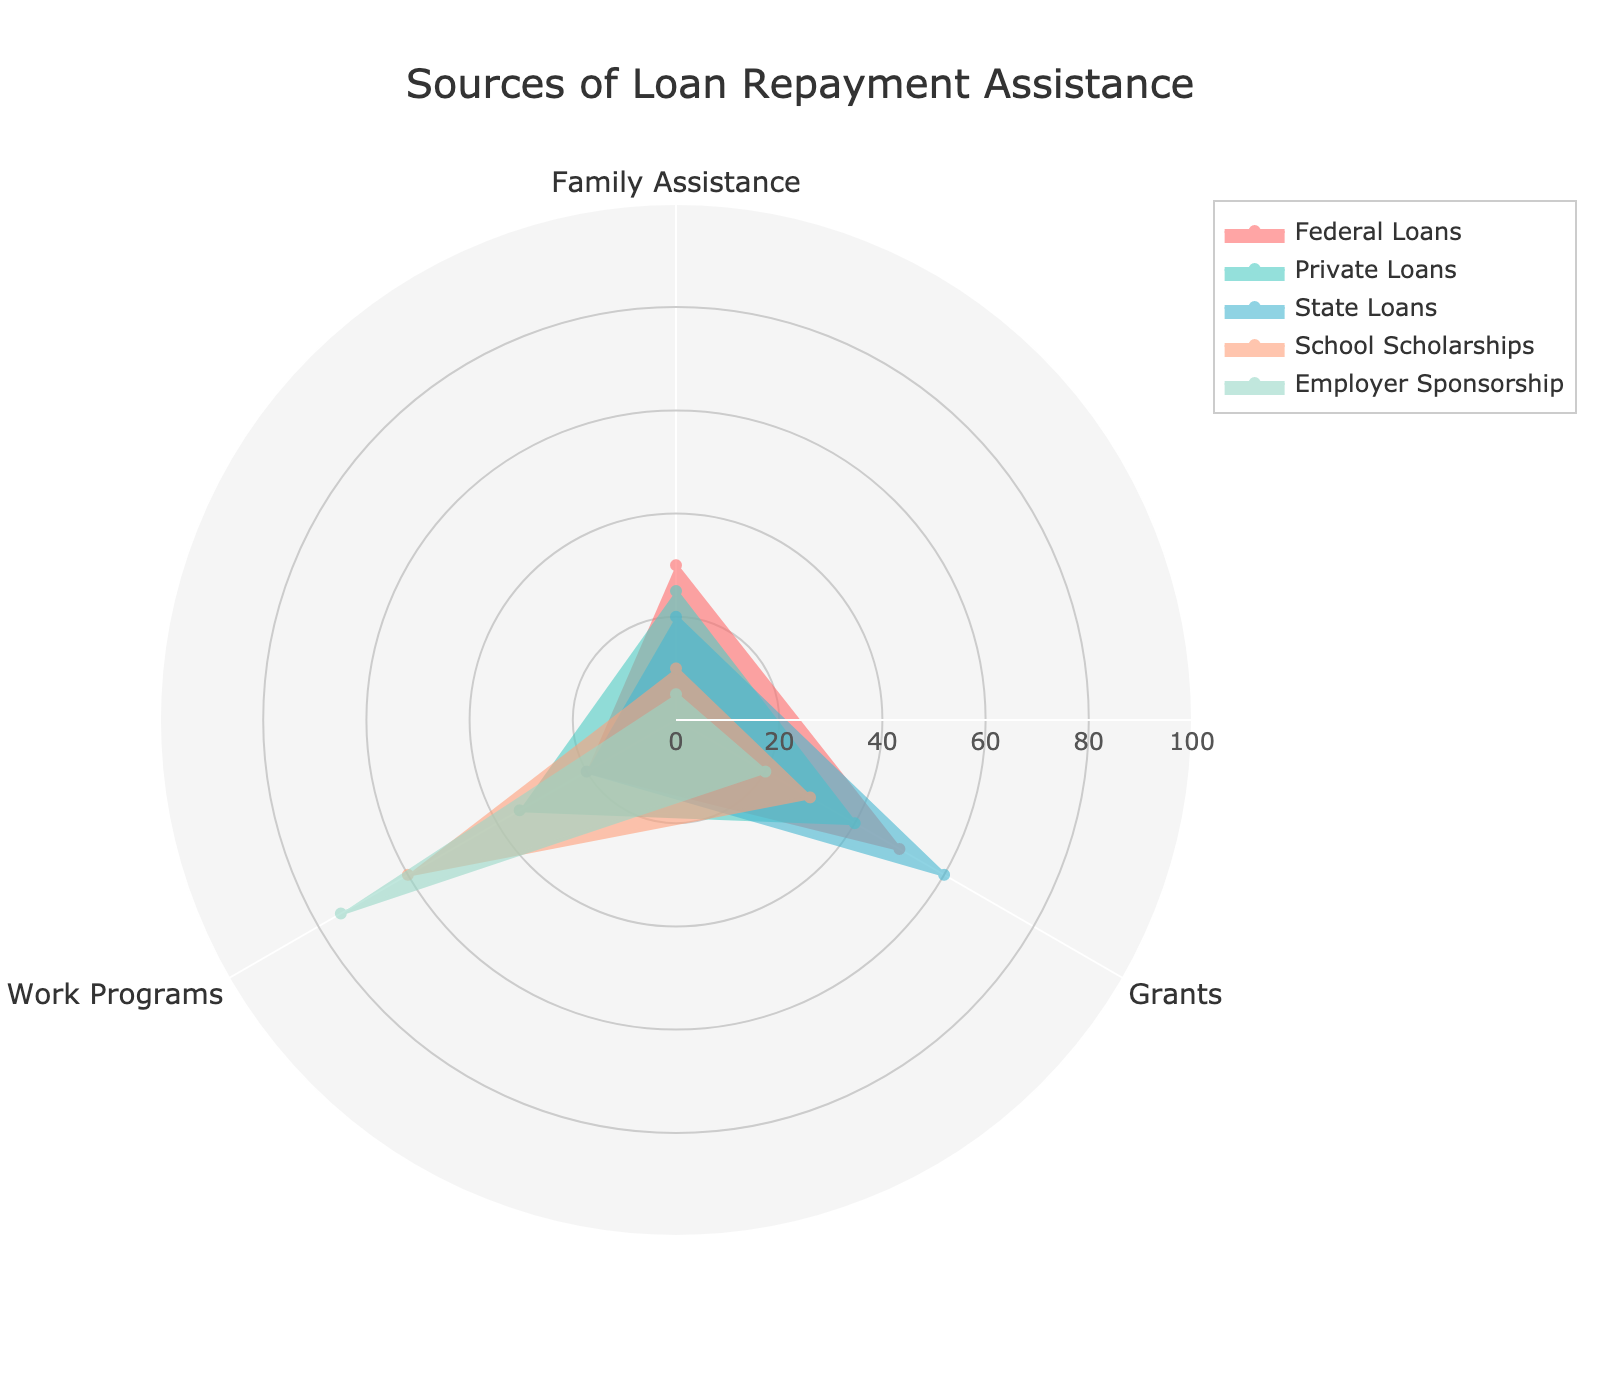What is the title of the radar chart? Read the title text placed at the top of the chart.
Answer: Sources of Loan Repayment Assistance Which income source has the highest assistance from grants? Compare the values for "Grants" across all income sources. The one with the highest value is the answer.
Answer: State Loans What is the average assistance from work programs across all income sources? List the work program values: 20, 35, 20, 60, 75. Sum these values (20 + 35 + 20 + 60 + 75 = 210). Divide by the number of sources (210 / 5 = 42).
Answer: 42 Which two income sources have the closest values for family assistance? Compare the family assistance values to find pairs that are numerically close: 30, 25, 20, 10, 5. The differences are 5 (30-25); the remaining pairs have larger differences.
Answer: Federal Loans and Private Loans Is employer sponsorship higher in work programs or in grants? Compare the values for "Work Programs" and "Grants" under "Employer Sponsorship": 75 (work programs) vs 20 (grants).
Answer: Work Programs Which income source shows the least assistance for family? Identify the lowest value in the "Family Assistance": 30, 25, 20, 10, 5.
Answer: Employer Sponsorship If you exclude School Scholarships, what is the new maximum value for work programs assistance? List the work programs values excluding School Scholarships: 20, 35, 20, 75. Identify the maximum value: 75.
Answer: 75 How much more assistance do State Loans have from Grants compared to Family? Subtract the "Family Assistance" value from the "Grants" value for State Loans: 60 (grants) - 20 (family) = 40.
Answer: 40 What is the total assistance from all sources for Private Loans? Sum the values for Private Loans under Family Assistance, Grants, and Work Programs: 25 + 40 + 35 = 100.
Answer: 100 Which income source has assistance values closest to the average family assistance? Calculate the average family assistance: (30 + 25 + 20 + 10 + 5) / 5 = 18. Compare each source to 18. State Loans at 20 is closest.
Answer: State Loans 